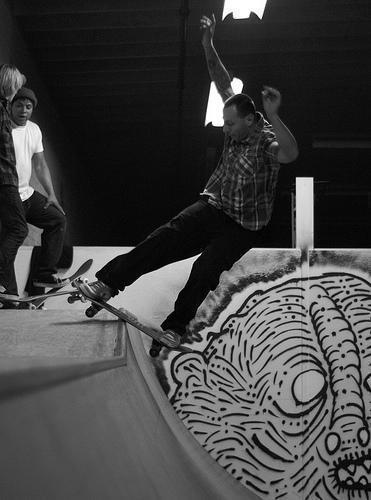What type of print is the man raising his hands wearing on his shirt?
Answer the question by selecting the correct answer among the 4 following choices.
Options: Animal, psychedelic, plaid, circular. Plaid. 